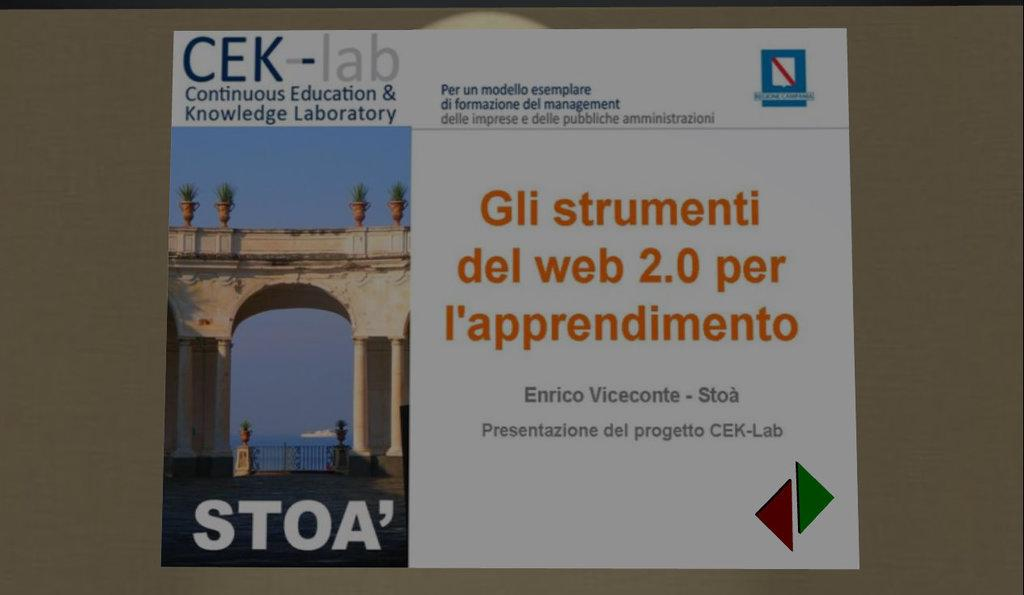<image>
Give a short and clear explanation of the subsequent image. A white postcard with Continuous Education and Knowledge Laboratory on it. 